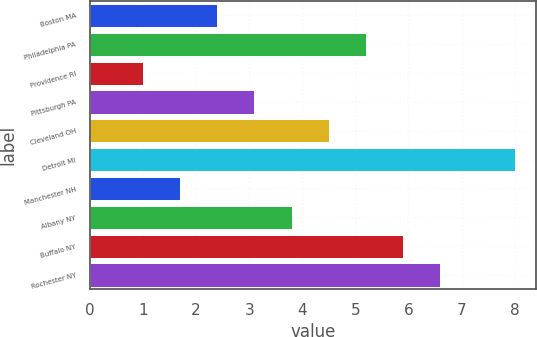<chart> <loc_0><loc_0><loc_500><loc_500><bar_chart><fcel>Boston MA<fcel>Philadelphia PA<fcel>Providence RI<fcel>Pittsburgh PA<fcel>Cleveland OH<fcel>Detroit MI<fcel>Manchester NH<fcel>Albany NY<fcel>Buffalo NY<fcel>Rochester NY<nl><fcel>2.4<fcel>5.2<fcel>1<fcel>3.1<fcel>4.5<fcel>8<fcel>1.7<fcel>3.8<fcel>5.9<fcel>6.6<nl></chart> 